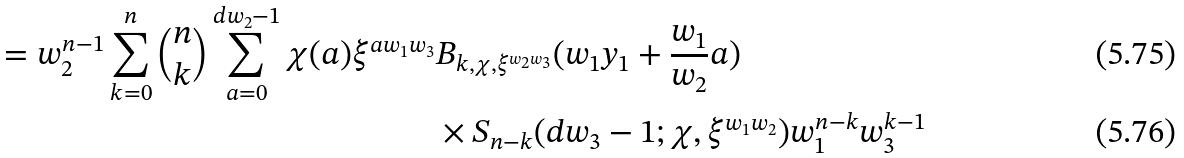Convert formula to latex. <formula><loc_0><loc_0><loc_500><loc_500>= w _ { 2 } ^ { n - 1 } \sum _ { k = 0 } ^ { n } \binom { n } { k } \sum _ { a = 0 } ^ { d w _ { 2 } - 1 } \chi ( a ) \xi ^ { a w _ { 1 } w _ { 3 } } & B _ { k , \chi , \xi ^ { w _ { 2 } w _ { 3 } } } ( w _ { 1 } y _ { 1 } + \frac { w _ { 1 } } { w _ { 2 } } a ) \\ & \times S _ { n - k } ( d w _ { 3 } - 1 ; \chi , \xi ^ { w _ { 1 } w _ { 2 } } ) w _ { 1 } ^ { n - k } w _ { 3 } ^ { k - 1 }</formula> 